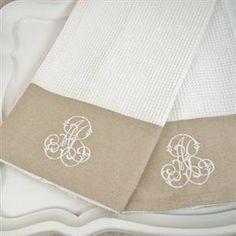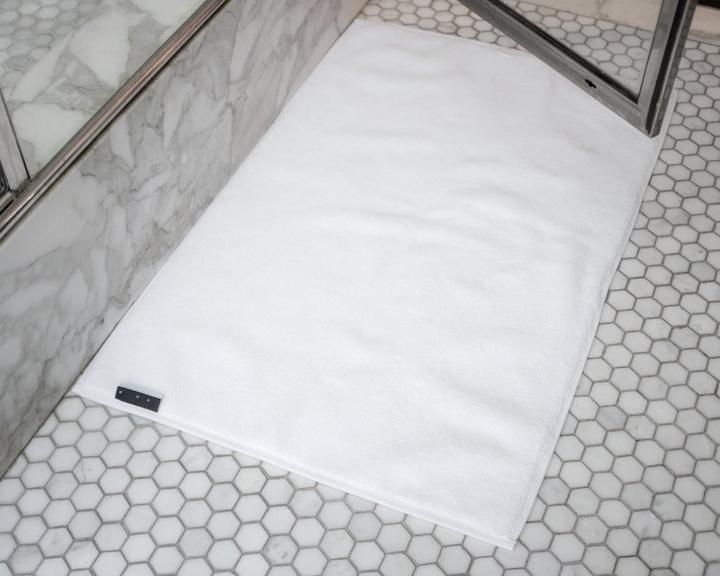The first image is the image on the left, the second image is the image on the right. Examine the images to the left and right. Is the description "One image includes gray and white towels with an all-over pattern." accurate? Answer yes or no. No. 